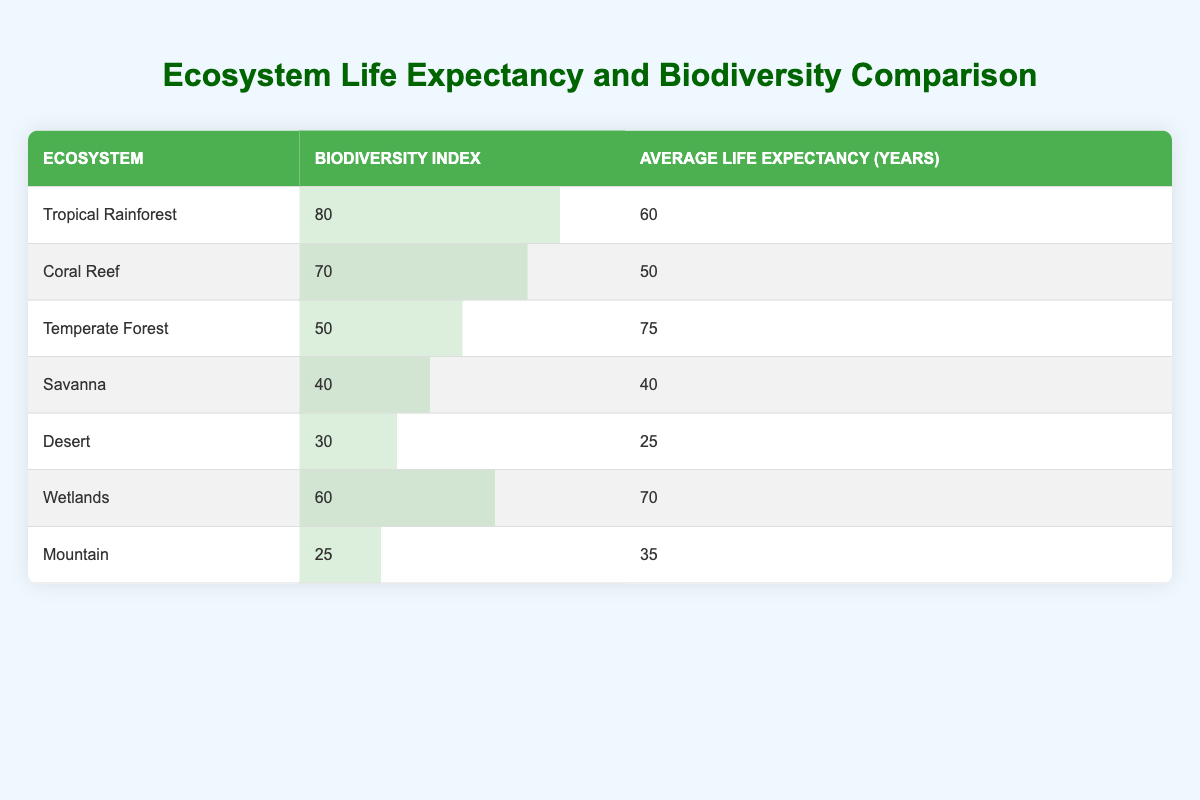What is the average life expectancy for the Tropical Rainforest ecosystem? The table lists the average life expectancy for the Tropical Rainforest as 60 years, which is directly stated in the relevant row.
Answer: 60 Which ecosystem has the highest biodiversity index? The Tropical Rainforest has the highest biodiversity index listed at 80, as seen in the second column of the first row.
Answer: Tropical Rainforest What is the difference in average life expectancy between the Desert and the Wetlands? The average life expectancy for the Desert is 25 years and for the Wetlands is 70 years. The difference can be calculated as 70 - 25 = 45 years.
Answer: 45 Is the average life expectancy of ecosystems with a biodiversity index below 40 higher than that of ecosystems with a biodiversity index above 40? The ecosystems with a biodiversity index below 40 are the Desert (25 years) and the Mountain (35 years), giving an average of (25 + 35)/2 = 30 years. The ecosystems above 40 (Tropical Rainforest, Coral Reef, Temperate Forest, Savanna, Wetlands) have an average of (60 + 50 + 75 + 40 + 70)/5 = 59 years. Therefore, it is false that the average is higher for the former.
Answer: No What is the average biodiversity index for all the ecosystems listed? The biodiversity indices are 80, 70, 50, 40, 30, 60, and 25. Adding these gives a total of 80 + 70 + 50 + 40 + 30 + 60 + 25 = 455. There are 7 ecosystems, so the average is 455/7 ≈ 65. Thus, the average biodiversity index is approximately 65.
Answer: 65 Does the Coral Reef have a higher life expectancy than the Desert? The Coral Reef's average life expectancy is 50 years, while the Desert's is 25 years. Since 50 is greater than 25, it is true that the Coral Reef has a higher life expectancy.
Answer: Yes 